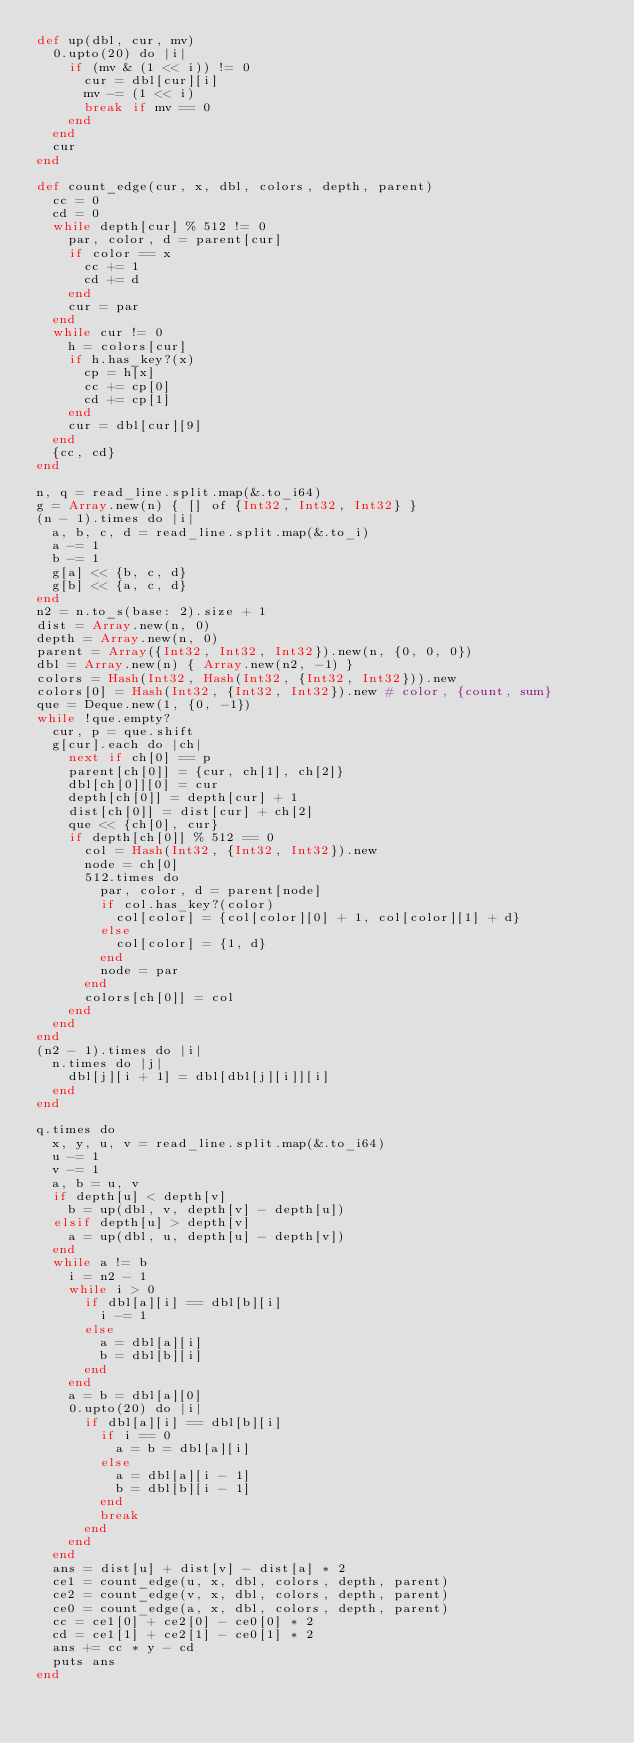<code> <loc_0><loc_0><loc_500><loc_500><_Crystal_>def up(dbl, cur, mv)
  0.upto(20) do |i|
    if (mv & (1 << i)) != 0
      cur = dbl[cur][i]
      mv -= (1 << i)
      break if mv == 0
    end
  end
  cur
end

def count_edge(cur, x, dbl, colors, depth, parent)
  cc = 0
  cd = 0
  while depth[cur] % 512 != 0
    par, color, d = parent[cur]
    if color == x
      cc += 1
      cd += d
    end
    cur = par
  end
  while cur != 0
    h = colors[cur]
    if h.has_key?(x)
      cp = h[x]
      cc += cp[0]
      cd += cp[1]
    end
    cur = dbl[cur][9]
  end
  {cc, cd}
end

n, q = read_line.split.map(&.to_i64)
g = Array.new(n) { [] of {Int32, Int32, Int32} }
(n - 1).times do |i|
  a, b, c, d = read_line.split.map(&.to_i)
  a -= 1
  b -= 1
  g[a] << {b, c, d}
  g[b] << {a, c, d}
end
n2 = n.to_s(base: 2).size + 1
dist = Array.new(n, 0)
depth = Array.new(n, 0)
parent = Array({Int32, Int32, Int32}).new(n, {0, 0, 0})
dbl = Array.new(n) { Array.new(n2, -1) }
colors = Hash(Int32, Hash(Int32, {Int32, Int32})).new
colors[0] = Hash(Int32, {Int32, Int32}).new # color, {count, sum}
que = Deque.new(1, {0, -1})
while !que.empty?
  cur, p = que.shift
  g[cur].each do |ch|
    next if ch[0] == p
    parent[ch[0]] = {cur, ch[1], ch[2]}
    dbl[ch[0]][0] = cur
    depth[ch[0]] = depth[cur] + 1
    dist[ch[0]] = dist[cur] + ch[2]
    que << {ch[0], cur}
    if depth[ch[0]] % 512 == 0
      col = Hash(Int32, {Int32, Int32}).new
      node = ch[0]
      512.times do
        par, color, d = parent[node]
        if col.has_key?(color)
          col[color] = {col[color][0] + 1, col[color][1] + d}
        else
          col[color] = {1, d}
        end
        node = par
      end
      colors[ch[0]] = col
    end
  end
end
(n2 - 1).times do |i|
  n.times do |j|
    dbl[j][i + 1] = dbl[dbl[j][i]][i]
  end
end

q.times do
  x, y, u, v = read_line.split.map(&.to_i64)
  u -= 1
  v -= 1
  a, b = u, v
  if depth[u] < depth[v]
    b = up(dbl, v, depth[v] - depth[u])
  elsif depth[u] > depth[v]
    a = up(dbl, u, depth[u] - depth[v])
  end
  while a != b
    i = n2 - 1
    while i > 0
      if dbl[a][i] == dbl[b][i]
        i -= 1
      else
        a = dbl[a][i]
        b = dbl[b][i]
      end
    end
    a = b = dbl[a][0]
    0.upto(20) do |i|
      if dbl[a][i] == dbl[b][i]
        if i == 0
          a = b = dbl[a][i]
        else
          a = dbl[a][i - 1]
          b = dbl[b][i - 1]
        end
        break
      end
    end
  end
  ans = dist[u] + dist[v] - dist[a] * 2
  ce1 = count_edge(u, x, dbl, colors, depth, parent)
  ce2 = count_edge(v, x, dbl, colors, depth, parent)
  ce0 = count_edge(a, x, dbl, colors, depth, parent)
  cc = ce1[0] + ce2[0] - ce0[0] * 2
  cd = ce1[1] + ce2[1] - ce0[1] * 2
  ans += cc * y - cd
  puts ans
end
</code> 